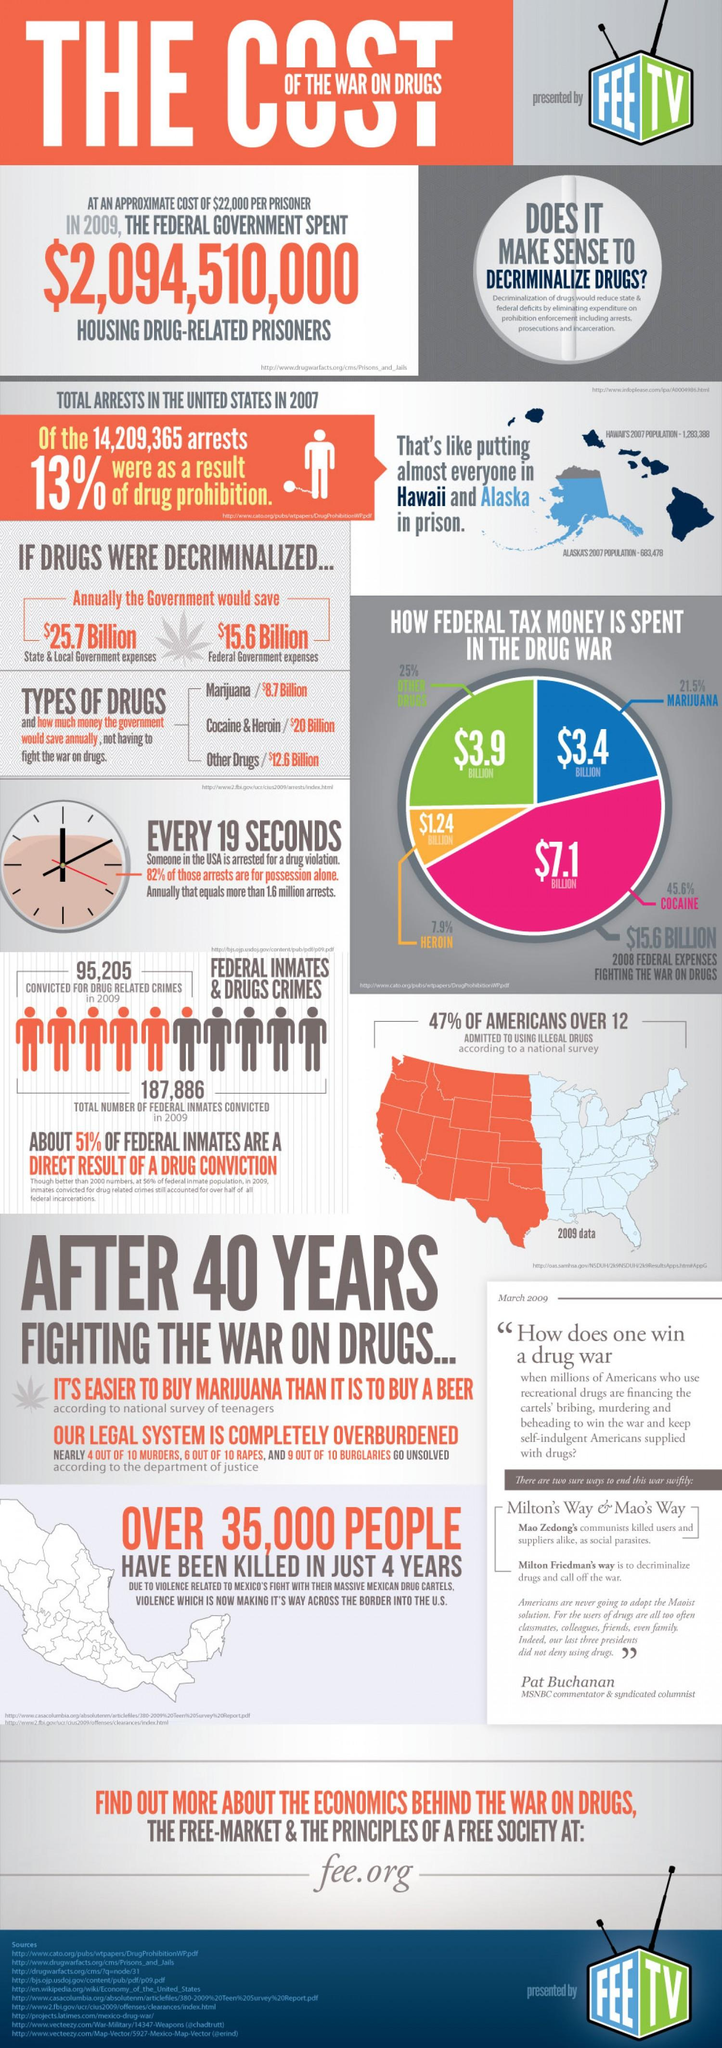Point out several critical features in this image. According to a survey, 47% of teenagers and adults admitted to using illegal drugs. The least amount of federal tax money is spent on the drug war in the area of heroin. In 2009, a total of 95,205 individuals were convicted for drug-related crimes. According to statistics from 2007, the number of people arrested was equal to the combined population of Hawaii and Alaska. If drugs were decriminalized, the federal government could potentially save $15.6 billion in expenses. 